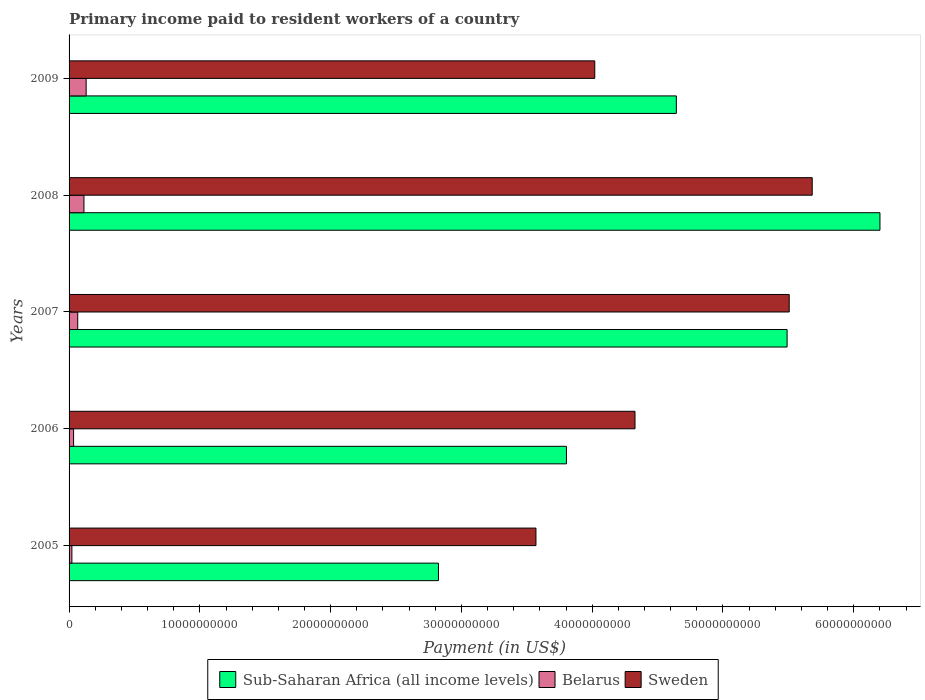Are the number of bars per tick equal to the number of legend labels?
Offer a very short reply. Yes. Are the number of bars on each tick of the Y-axis equal?
Provide a short and direct response. Yes. What is the amount paid to workers in Belarus in 2005?
Your answer should be very brief. 2.16e+08. Across all years, what is the maximum amount paid to workers in Sweden?
Give a very brief answer. 5.68e+1. Across all years, what is the minimum amount paid to workers in Sub-Saharan Africa (all income levels)?
Offer a terse response. 2.82e+1. In which year was the amount paid to workers in Sweden maximum?
Your answer should be compact. 2008. What is the total amount paid to workers in Sub-Saharan Africa (all income levels) in the graph?
Make the answer very short. 2.30e+11. What is the difference between the amount paid to workers in Sweden in 2007 and that in 2008?
Offer a very short reply. -1.76e+09. What is the difference between the amount paid to workers in Sub-Saharan Africa (all income levels) in 2008 and the amount paid to workers in Sweden in 2007?
Your answer should be compact. 6.94e+09. What is the average amount paid to workers in Sub-Saharan Africa (all income levels) per year?
Your answer should be compact. 4.59e+1. In the year 2009, what is the difference between the amount paid to workers in Sub-Saharan Africa (all income levels) and amount paid to workers in Belarus?
Give a very brief answer. 4.51e+1. What is the ratio of the amount paid to workers in Belarus in 2005 to that in 2009?
Give a very brief answer. 0.17. Is the amount paid to workers in Sweden in 2008 less than that in 2009?
Give a very brief answer. No. Is the difference between the amount paid to workers in Sub-Saharan Africa (all income levels) in 2005 and 2007 greater than the difference between the amount paid to workers in Belarus in 2005 and 2007?
Your response must be concise. No. What is the difference between the highest and the second highest amount paid to workers in Belarus?
Keep it short and to the point. 1.69e+08. What is the difference between the highest and the lowest amount paid to workers in Sweden?
Offer a terse response. 2.11e+1. In how many years, is the amount paid to workers in Sub-Saharan Africa (all income levels) greater than the average amount paid to workers in Sub-Saharan Africa (all income levels) taken over all years?
Offer a terse response. 3. What does the 2nd bar from the top in 2005 represents?
Provide a short and direct response. Belarus. What does the 2nd bar from the bottom in 2007 represents?
Your response must be concise. Belarus. Is it the case that in every year, the sum of the amount paid to workers in Sub-Saharan Africa (all income levels) and amount paid to workers in Sweden is greater than the amount paid to workers in Belarus?
Make the answer very short. Yes. How many bars are there?
Give a very brief answer. 15. How many legend labels are there?
Provide a short and direct response. 3. How are the legend labels stacked?
Give a very brief answer. Horizontal. What is the title of the graph?
Your response must be concise. Primary income paid to resident workers of a country. What is the label or title of the X-axis?
Provide a short and direct response. Payment (in US$). What is the Payment (in US$) in Sub-Saharan Africa (all income levels) in 2005?
Ensure brevity in your answer.  2.82e+1. What is the Payment (in US$) of Belarus in 2005?
Offer a very short reply. 2.16e+08. What is the Payment (in US$) of Sweden in 2005?
Give a very brief answer. 3.57e+1. What is the Payment (in US$) in Sub-Saharan Africa (all income levels) in 2006?
Give a very brief answer. 3.80e+1. What is the Payment (in US$) of Belarus in 2006?
Keep it short and to the point. 3.46e+08. What is the Payment (in US$) in Sweden in 2006?
Keep it short and to the point. 4.33e+1. What is the Payment (in US$) of Sub-Saharan Africa (all income levels) in 2007?
Your answer should be compact. 5.49e+1. What is the Payment (in US$) of Belarus in 2007?
Offer a terse response. 6.62e+08. What is the Payment (in US$) of Sweden in 2007?
Offer a terse response. 5.51e+1. What is the Payment (in US$) in Sub-Saharan Africa (all income levels) in 2008?
Ensure brevity in your answer.  6.20e+1. What is the Payment (in US$) in Belarus in 2008?
Make the answer very short. 1.14e+09. What is the Payment (in US$) of Sweden in 2008?
Make the answer very short. 5.68e+1. What is the Payment (in US$) in Sub-Saharan Africa (all income levels) in 2009?
Keep it short and to the point. 4.64e+1. What is the Payment (in US$) in Belarus in 2009?
Give a very brief answer. 1.31e+09. What is the Payment (in US$) of Sweden in 2009?
Your answer should be compact. 4.02e+1. Across all years, what is the maximum Payment (in US$) of Sub-Saharan Africa (all income levels)?
Your answer should be very brief. 6.20e+1. Across all years, what is the maximum Payment (in US$) of Belarus?
Make the answer very short. 1.31e+09. Across all years, what is the maximum Payment (in US$) of Sweden?
Your answer should be compact. 5.68e+1. Across all years, what is the minimum Payment (in US$) of Sub-Saharan Africa (all income levels)?
Give a very brief answer. 2.82e+1. Across all years, what is the minimum Payment (in US$) in Belarus?
Give a very brief answer. 2.16e+08. Across all years, what is the minimum Payment (in US$) in Sweden?
Your answer should be very brief. 3.57e+1. What is the total Payment (in US$) of Sub-Saharan Africa (all income levels) in the graph?
Offer a terse response. 2.30e+11. What is the total Payment (in US$) in Belarus in the graph?
Keep it short and to the point. 3.67e+09. What is the total Payment (in US$) of Sweden in the graph?
Keep it short and to the point. 2.31e+11. What is the difference between the Payment (in US$) of Sub-Saharan Africa (all income levels) in 2005 and that in 2006?
Make the answer very short. -9.79e+09. What is the difference between the Payment (in US$) in Belarus in 2005 and that in 2006?
Your answer should be very brief. -1.30e+08. What is the difference between the Payment (in US$) of Sweden in 2005 and that in 2006?
Make the answer very short. -7.57e+09. What is the difference between the Payment (in US$) of Sub-Saharan Africa (all income levels) in 2005 and that in 2007?
Give a very brief answer. -2.67e+1. What is the difference between the Payment (in US$) in Belarus in 2005 and that in 2007?
Provide a short and direct response. -4.46e+08. What is the difference between the Payment (in US$) of Sweden in 2005 and that in 2007?
Keep it short and to the point. -1.94e+1. What is the difference between the Payment (in US$) in Sub-Saharan Africa (all income levels) in 2005 and that in 2008?
Offer a terse response. -3.38e+1. What is the difference between the Payment (in US$) in Belarus in 2005 and that in 2008?
Your response must be concise. -9.21e+08. What is the difference between the Payment (in US$) of Sweden in 2005 and that in 2008?
Make the answer very short. -2.11e+1. What is the difference between the Payment (in US$) in Sub-Saharan Africa (all income levels) in 2005 and that in 2009?
Provide a short and direct response. -1.82e+1. What is the difference between the Payment (in US$) in Belarus in 2005 and that in 2009?
Your response must be concise. -1.09e+09. What is the difference between the Payment (in US$) of Sweden in 2005 and that in 2009?
Keep it short and to the point. -4.50e+09. What is the difference between the Payment (in US$) of Sub-Saharan Africa (all income levels) in 2006 and that in 2007?
Make the answer very short. -1.69e+1. What is the difference between the Payment (in US$) in Belarus in 2006 and that in 2007?
Provide a short and direct response. -3.16e+08. What is the difference between the Payment (in US$) of Sweden in 2006 and that in 2007?
Provide a short and direct response. -1.18e+1. What is the difference between the Payment (in US$) of Sub-Saharan Africa (all income levels) in 2006 and that in 2008?
Make the answer very short. -2.40e+1. What is the difference between the Payment (in US$) in Belarus in 2006 and that in 2008?
Ensure brevity in your answer.  -7.91e+08. What is the difference between the Payment (in US$) in Sweden in 2006 and that in 2008?
Provide a succinct answer. -1.35e+1. What is the difference between the Payment (in US$) of Sub-Saharan Africa (all income levels) in 2006 and that in 2009?
Keep it short and to the point. -8.40e+09. What is the difference between the Payment (in US$) in Belarus in 2006 and that in 2009?
Offer a terse response. -9.60e+08. What is the difference between the Payment (in US$) of Sweden in 2006 and that in 2009?
Your answer should be compact. 3.08e+09. What is the difference between the Payment (in US$) of Sub-Saharan Africa (all income levels) in 2007 and that in 2008?
Provide a short and direct response. -7.10e+09. What is the difference between the Payment (in US$) in Belarus in 2007 and that in 2008?
Your answer should be very brief. -4.75e+08. What is the difference between the Payment (in US$) of Sweden in 2007 and that in 2008?
Your answer should be compact. -1.76e+09. What is the difference between the Payment (in US$) of Sub-Saharan Africa (all income levels) in 2007 and that in 2009?
Make the answer very short. 8.47e+09. What is the difference between the Payment (in US$) in Belarus in 2007 and that in 2009?
Provide a short and direct response. -6.44e+08. What is the difference between the Payment (in US$) in Sweden in 2007 and that in 2009?
Keep it short and to the point. 1.49e+1. What is the difference between the Payment (in US$) of Sub-Saharan Africa (all income levels) in 2008 and that in 2009?
Provide a succinct answer. 1.56e+1. What is the difference between the Payment (in US$) in Belarus in 2008 and that in 2009?
Provide a short and direct response. -1.69e+08. What is the difference between the Payment (in US$) in Sweden in 2008 and that in 2009?
Provide a succinct answer. 1.66e+1. What is the difference between the Payment (in US$) in Sub-Saharan Africa (all income levels) in 2005 and the Payment (in US$) in Belarus in 2006?
Offer a terse response. 2.79e+1. What is the difference between the Payment (in US$) of Sub-Saharan Africa (all income levels) in 2005 and the Payment (in US$) of Sweden in 2006?
Provide a short and direct response. -1.50e+1. What is the difference between the Payment (in US$) in Belarus in 2005 and the Payment (in US$) in Sweden in 2006?
Provide a succinct answer. -4.31e+1. What is the difference between the Payment (in US$) in Sub-Saharan Africa (all income levels) in 2005 and the Payment (in US$) in Belarus in 2007?
Your response must be concise. 2.76e+1. What is the difference between the Payment (in US$) of Sub-Saharan Africa (all income levels) in 2005 and the Payment (in US$) of Sweden in 2007?
Ensure brevity in your answer.  -2.68e+1. What is the difference between the Payment (in US$) of Belarus in 2005 and the Payment (in US$) of Sweden in 2007?
Your answer should be very brief. -5.48e+1. What is the difference between the Payment (in US$) of Sub-Saharan Africa (all income levels) in 2005 and the Payment (in US$) of Belarus in 2008?
Offer a terse response. 2.71e+1. What is the difference between the Payment (in US$) of Sub-Saharan Africa (all income levels) in 2005 and the Payment (in US$) of Sweden in 2008?
Your answer should be very brief. -2.86e+1. What is the difference between the Payment (in US$) of Belarus in 2005 and the Payment (in US$) of Sweden in 2008?
Ensure brevity in your answer.  -5.66e+1. What is the difference between the Payment (in US$) in Sub-Saharan Africa (all income levels) in 2005 and the Payment (in US$) in Belarus in 2009?
Your answer should be very brief. 2.69e+1. What is the difference between the Payment (in US$) in Sub-Saharan Africa (all income levels) in 2005 and the Payment (in US$) in Sweden in 2009?
Your answer should be compact. -1.20e+1. What is the difference between the Payment (in US$) in Belarus in 2005 and the Payment (in US$) in Sweden in 2009?
Offer a very short reply. -4.00e+1. What is the difference between the Payment (in US$) of Sub-Saharan Africa (all income levels) in 2006 and the Payment (in US$) of Belarus in 2007?
Keep it short and to the point. 3.74e+1. What is the difference between the Payment (in US$) of Sub-Saharan Africa (all income levels) in 2006 and the Payment (in US$) of Sweden in 2007?
Your answer should be very brief. -1.70e+1. What is the difference between the Payment (in US$) in Belarus in 2006 and the Payment (in US$) in Sweden in 2007?
Offer a very short reply. -5.47e+1. What is the difference between the Payment (in US$) in Sub-Saharan Africa (all income levels) in 2006 and the Payment (in US$) in Belarus in 2008?
Provide a succinct answer. 3.69e+1. What is the difference between the Payment (in US$) of Sub-Saharan Africa (all income levels) in 2006 and the Payment (in US$) of Sweden in 2008?
Your response must be concise. -1.88e+1. What is the difference between the Payment (in US$) in Belarus in 2006 and the Payment (in US$) in Sweden in 2008?
Ensure brevity in your answer.  -5.65e+1. What is the difference between the Payment (in US$) of Sub-Saharan Africa (all income levels) in 2006 and the Payment (in US$) of Belarus in 2009?
Provide a short and direct response. 3.67e+1. What is the difference between the Payment (in US$) in Sub-Saharan Africa (all income levels) in 2006 and the Payment (in US$) in Sweden in 2009?
Offer a very short reply. -2.17e+09. What is the difference between the Payment (in US$) in Belarus in 2006 and the Payment (in US$) in Sweden in 2009?
Offer a terse response. -3.99e+1. What is the difference between the Payment (in US$) of Sub-Saharan Africa (all income levels) in 2007 and the Payment (in US$) of Belarus in 2008?
Provide a succinct answer. 5.38e+1. What is the difference between the Payment (in US$) of Sub-Saharan Africa (all income levels) in 2007 and the Payment (in US$) of Sweden in 2008?
Give a very brief answer. -1.92e+09. What is the difference between the Payment (in US$) in Belarus in 2007 and the Payment (in US$) in Sweden in 2008?
Keep it short and to the point. -5.62e+1. What is the difference between the Payment (in US$) in Sub-Saharan Africa (all income levels) in 2007 and the Payment (in US$) in Belarus in 2009?
Ensure brevity in your answer.  5.36e+1. What is the difference between the Payment (in US$) in Sub-Saharan Africa (all income levels) in 2007 and the Payment (in US$) in Sweden in 2009?
Offer a very short reply. 1.47e+1. What is the difference between the Payment (in US$) of Belarus in 2007 and the Payment (in US$) of Sweden in 2009?
Make the answer very short. -3.95e+1. What is the difference between the Payment (in US$) of Sub-Saharan Africa (all income levels) in 2008 and the Payment (in US$) of Belarus in 2009?
Your response must be concise. 6.07e+1. What is the difference between the Payment (in US$) in Sub-Saharan Africa (all income levels) in 2008 and the Payment (in US$) in Sweden in 2009?
Keep it short and to the point. 2.18e+1. What is the difference between the Payment (in US$) of Belarus in 2008 and the Payment (in US$) of Sweden in 2009?
Provide a short and direct response. -3.91e+1. What is the average Payment (in US$) in Sub-Saharan Africa (all income levels) per year?
Your answer should be very brief. 4.59e+1. What is the average Payment (in US$) of Belarus per year?
Make the answer very short. 7.34e+08. What is the average Payment (in US$) of Sweden per year?
Provide a short and direct response. 4.62e+1. In the year 2005, what is the difference between the Payment (in US$) of Sub-Saharan Africa (all income levels) and Payment (in US$) of Belarus?
Provide a short and direct response. 2.80e+1. In the year 2005, what is the difference between the Payment (in US$) of Sub-Saharan Africa (all income levels) and Payment (in US$) of Sweden?
Your answer should be compact. -7.46e+09. In the year 2005, what is the difference between the Payment (in US$) in Belarus and Payment (in US$) in Sweden?
Provide a succinct answer. -3.55e+1. In the year 2006, what is the difference between the Payment (in US$) of Sub-Saharan Africa (all income levels) and Payment (in US$) of Belarus?
Provide a succinct answer. 3.77e+1. In the year 2006, what is the difference between the Payment (in US$) in Sub-Saharan Africa (all income levels) and Payment (in US$) in Sweden?
Keep it short and to the point. -5.24e+09. In the year 2006, what is the difference between the Payment (in US$) in Belarus and Payment (in US$) in Sweden?
Offer a very short reply. -4.29e+1. In the year 2007, what is the difference between the Payment (in US$) in Sub-Saharan Africa (all income levels) and Payment (in US$) in Belarus?
Make the answer very short. 5.42e+1. In the year 2007, what is the difference between the Payment (in US$) of Sub-Saharan Africa (all income levels) and Payment (in US$) of Sweden?
Ensure brevity in your answer.  -1.63e+08. In the year 2007, what is the difference between the Payment (in US$) in Belarus and Payment (in US$) in Sweden?
Give a very brief answer. -5.44e+1. In the year 2008, what is the difference between the Payment (in US$) of Sub-Saharan Africa (all income levels) and Payment (in US$) of Belarus?
Offer a very short reply. 6.09e+1. In the year 2008, what is the difference between the Payment (in US$) of Sub-Saharan Africa (all income levels) and Payment (in US$) of Sweden?
Your answer should be very brief. 5.18e+09. In the year 2008, what is the difference between the Payment (in US$) in Belarus and Payment (in US$) in Sweden?
Provide a short and direct response. -5.57e+1. In the year 2009, what is the difference between the Payment (in US$) of Sub-Saharan Africa (all income levels) and Payment (in US$) of Belarus?
Keep it short and to the point. 4.51e+1. In the year 2009, what is the difference between the Payment (in US$) in Sub-Saharan Africa (all income levels) and Payment (in US$) in Sweden?
Provide a short and direct response. 6.24e+09. In the year 2009, what is the difference between the Payment (in US$) in Belarus and Payment (in US$) in Sweden?
Provide a succinct answer. -3.89e+1. What is the ratio of the Payment (in US$) in Sub-Saharan Africa (all income levels) in 2005 to that in 2006?
Give a very brief answer. 0.74. What is the ratio of the Payment (in US$) in Belarus in 2005 to that in 2006?
Offer a very short reply. 0.62. What is the ratio of the Payment (in US$) of Sweden in 2005 to that in 2006?
Give a very brief answer. 0.82. What is the ratio of the Payment (in US$) in Sub-Saharan Africa (all income levels) in 2005 to that in 2007?
Your response must be concise. 0.51. What is the ratio of the Payment (in US$) of Belarus in 2005 to that in 2007?
Your answer should be very brief. 0.33. What is the ratio of the Payment (in US$) in Sweden in 2005 to that in 2007?
Your answer should be compact. 0.65. What is the ratio of the Payment (in US$) of Sub-Saharan Africa (all income levels) in 2005 to that in 2008?
Make the answer very short. 0.46. What is the ratio of the Payment (in US$) in Belarus in 2005 to that in 2008?
Provide a succinct answer. 0.19. What is the ratio of the Payment (in US$) in Sweden in 2005 to that in 2008?
Your answer should be compact. 0.63. What is the ratio of the Payment (in US$) of Sub-Saharan Africa (all income levels) in 2005 to that in 2009?
Your answer should be compact. 0.61. What is the ratio of the Payment (in US$) of Belarus in 2005 to that in 2009?
Ensure brevity in your answer.  0.17. What is the ratio of the Payment (in US$) in Sweden in 2005 to that in 2009?
Offer a very short reply. 0.89. What is the ratio of the Payment (in US$) in Sub-Saharan Africa (all income levels) in 2006 to that in 2007?
Offer a very short reply. 0.69. What is the ratio of the Payment (in US$) of Belarus in 2006 to that in 2007?
Provide a short and direct response. 0.52. What is the ratio of the Payment (in US$) of Sweden in 2006 to that in 2007?
Offer a very short reply. 0.79. What is the ratio of the Payment (in US$) of Sub-Saharan Africa (all income levels) in 2006 to that in 2008?
Give a very brief answer. 0.61. What is the ratio of the Payment (in US$) of Belarus in 2006 to that in 2008?
Offer a very short reply. 0.3. What is the ratio of the Payment (in US$) in Sweden in 2006 to that in 2008?
Offer a terse response. 0.76. What is the ratio of the Payment (in US$) in Sub-Saharan Africa (all income levels) in 2006 to that in 2009?
Your response must be concise. 0.82. What is the ratio of the Payment (in US$) of Belarus in 2006 to that in 2009?
Your answer should be very brief. 0.27. What is the ratio of the Payment (in US$) in Sweden in 2006 to that in 2009?
Your answer should be compact. 1.08. What is the ratio of the Payment (in US$) in Sub-Saharan Africa (all income levels) in 2007 to that in 2008?
Offer a very short reply. 0.89. What is the ratio of the Payment (in US$) in Belarus in 2007 to that in 2008?
Give a very brief answer. 0.58. What is the ratio of the Payment (in US$) in Sweden in 2007 to that in 2008?
Keep it short and to the point. 0.97. What is the ratio of the Payment (in US$) of Sub-Saharan Africa (all income levels) in 2007 to that in 2009?
Make the answer very short. 1.18. What is the ratio of the Payment (in US$) of Belarus in 2007 to that in 2009?
Provide a short and direct response. 0.51. What is the ratio of the Payment (in US$) in Sweden in 2007 to that in 2009?
Make the answer very short. 1.37. What is the ratio of the Payment (in US$) of Sub-Saharan Africa (all income levels) in 2008 to that in 2009?
Your response must be concise. 1.34. What is the ratio of the Payment (in US$) of Belarus in 2008 to that in 2009?
Offer a very short reply. 0.87. What is the ratio of the Payment (in US$) of Sweden in 2008 to that in 2009?
Ensure brevity in your answer.  1.41. What is the difference between the highest and the second highest Payment (in US$) of Sub-Saharan Africa (all income levels)?
Offer a very short reply. 7.10e+09. What is the difference between the highest and the second highest Payment (in US$) of Belarus?
Your response must be concise. 1.69e+08. What is the difference between the highest and the second highest Payment (in US$) of Sweden?
Offer a very short reply. 1.76e+09. What is the difference between the highest and the lowest Payment (in US$) of Sub-Saharan Africa (all income levels)?
Make the answer very short. 3.38e+1. What is the difference between the highest and the lowest Payment (in US$) in Belarus?
Make the answer very short. 1.09e+09. What is the difference between the highest and the lowest Payment (in US$) in Sweden?
Give a very brief answer. 2.11e+1. 